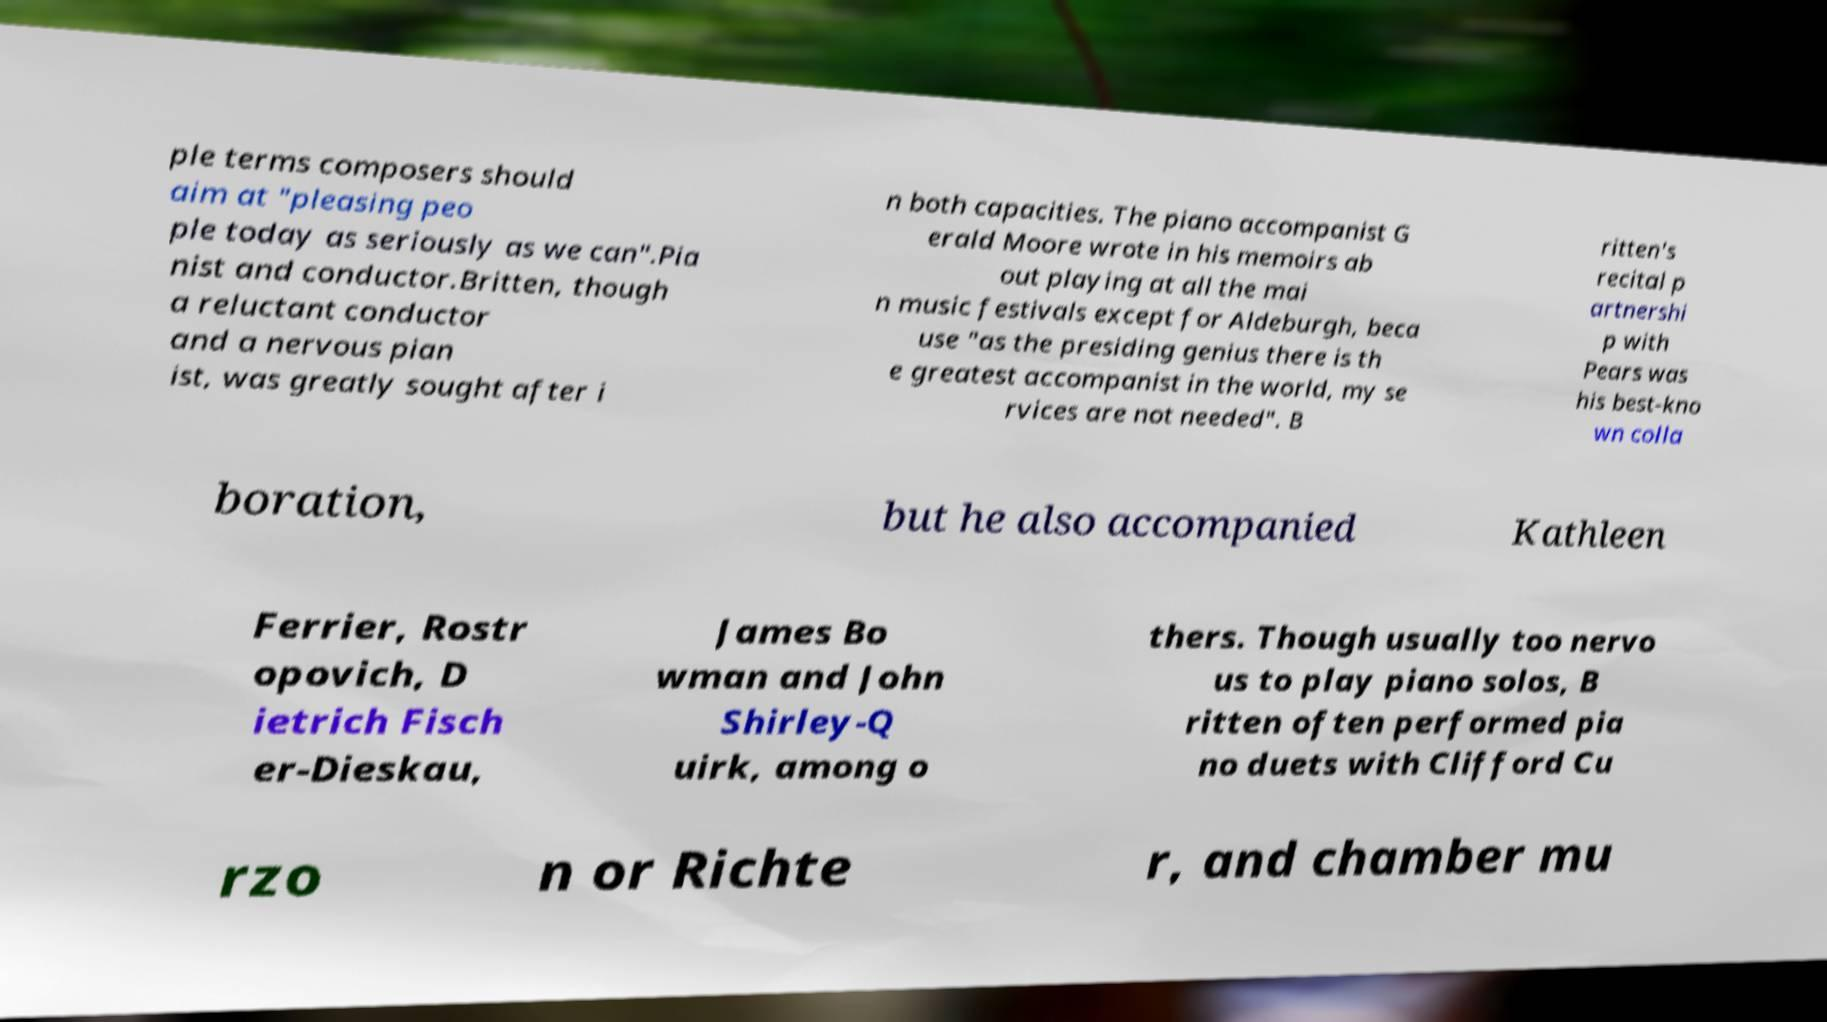For documentation purposes, I need the text within this image transcribed. Could you provide that? ple terms composers should aim at "pleasing peo ple today as seriously as we can".Pia nist and conductor.Britten, though a reluctant conductor and a nervous pian ist, was greatly sought after i n both capacities. The piano accompanist G erald Moore wrote in his memoirs ab out playing at all the mai n music festivals except for Aldeburgh, beca use "as the presiding genius there is th e greatest accompanist in the world, my se rvices are not needed". B ritten's recital p artnershi p with Pears was his best-kno wn colla boration, but he also accompanied Kathleen Ferrier, Rostr opovich, D ietrich Fisch er-Dieskau, James Bo wman and John Shirley-Q uirk, among o thers. Though usually too nervo us to play piano solos, B ritten often performed pia no duets with Clifford Cu rzo n or Richte r, and chamber mu 